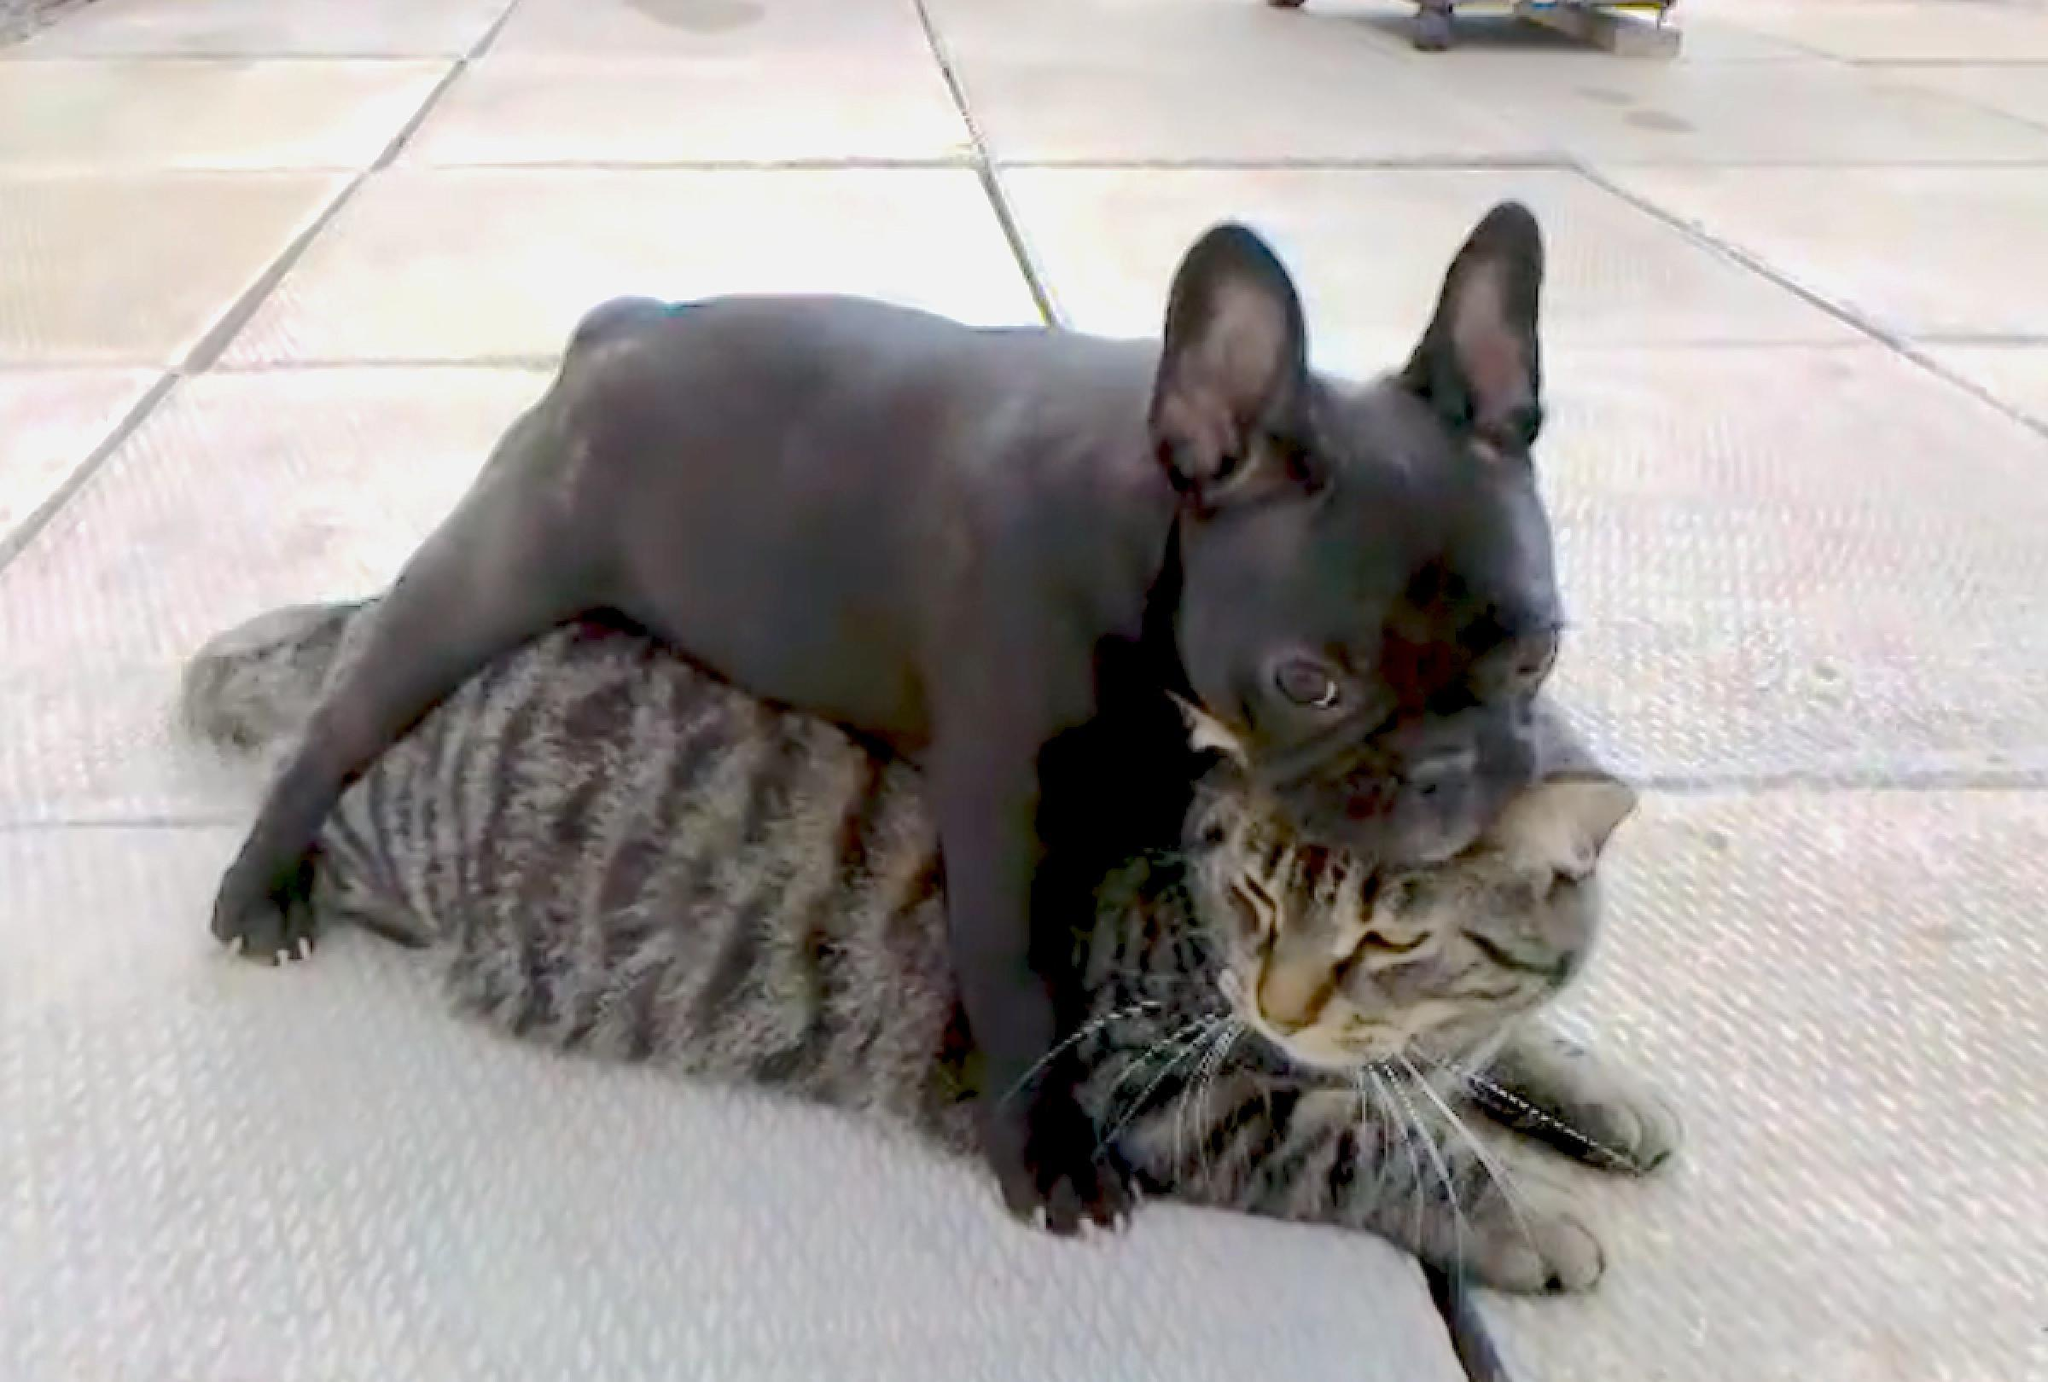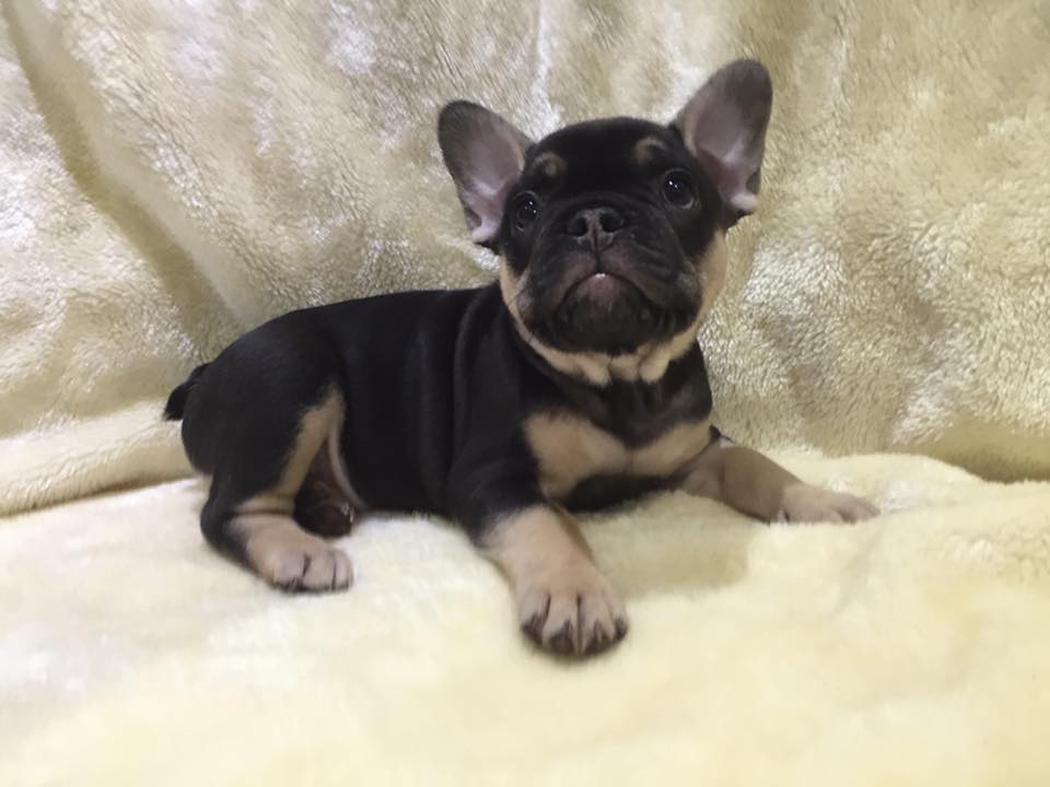The first image is the image on the left, the second image is the image on the right. Given the left and right images, does the statement "One dog has something in his mouth." hold true? Answer yes or no. No. The first image is the image on the left, the second image is the image on the right. Assess this claim about the two images: "The left image shows a black french bulldog pup posed with another animal figure with upright ears.". Correct or not? Answer yes or no. Yes. 